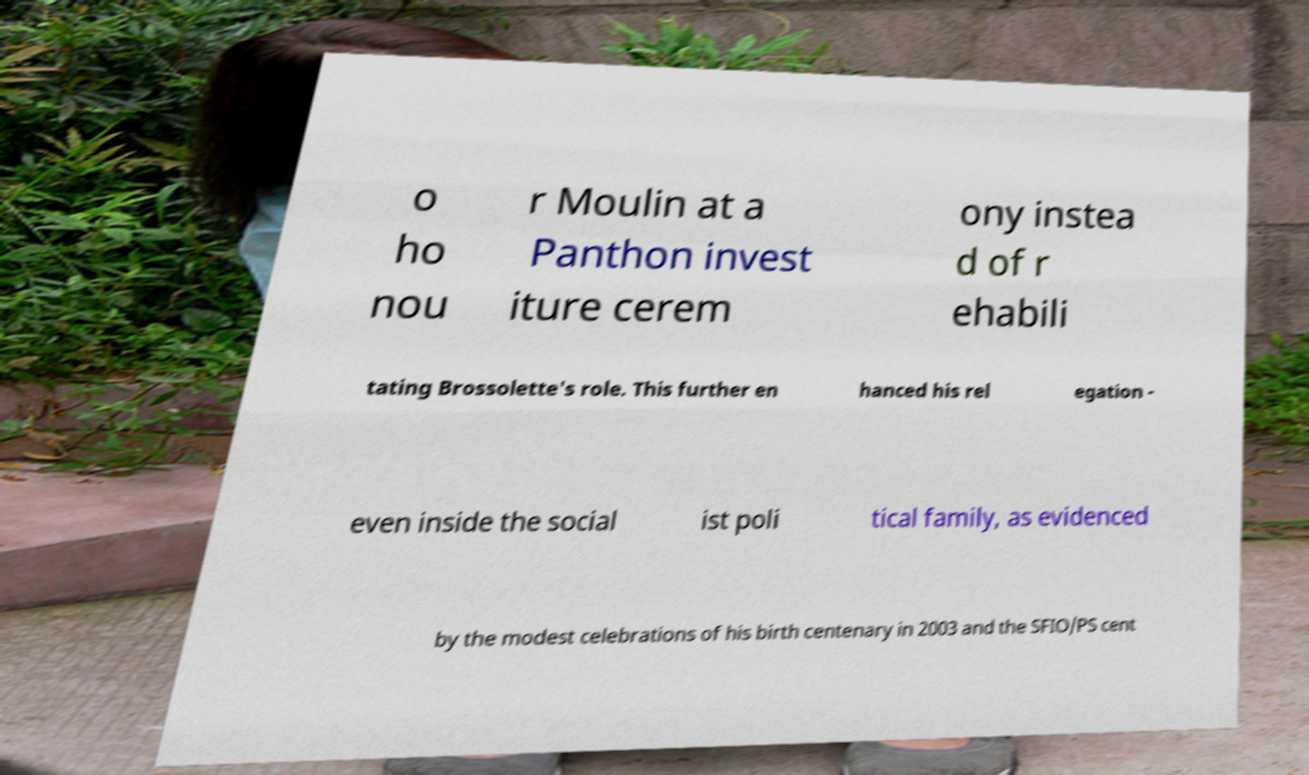Can you accurately transcribe the text from the provided image for me? o ho nou r Moulin at a Panthon invest iture cerem ony instea d of r ehabili tating Brossolette's role. This further en hanced his rel egation - even inside the social ist poli tical family, as evidenced by the modest celebrations of his birth centenary in 2003 and the SFIO/PS cent 